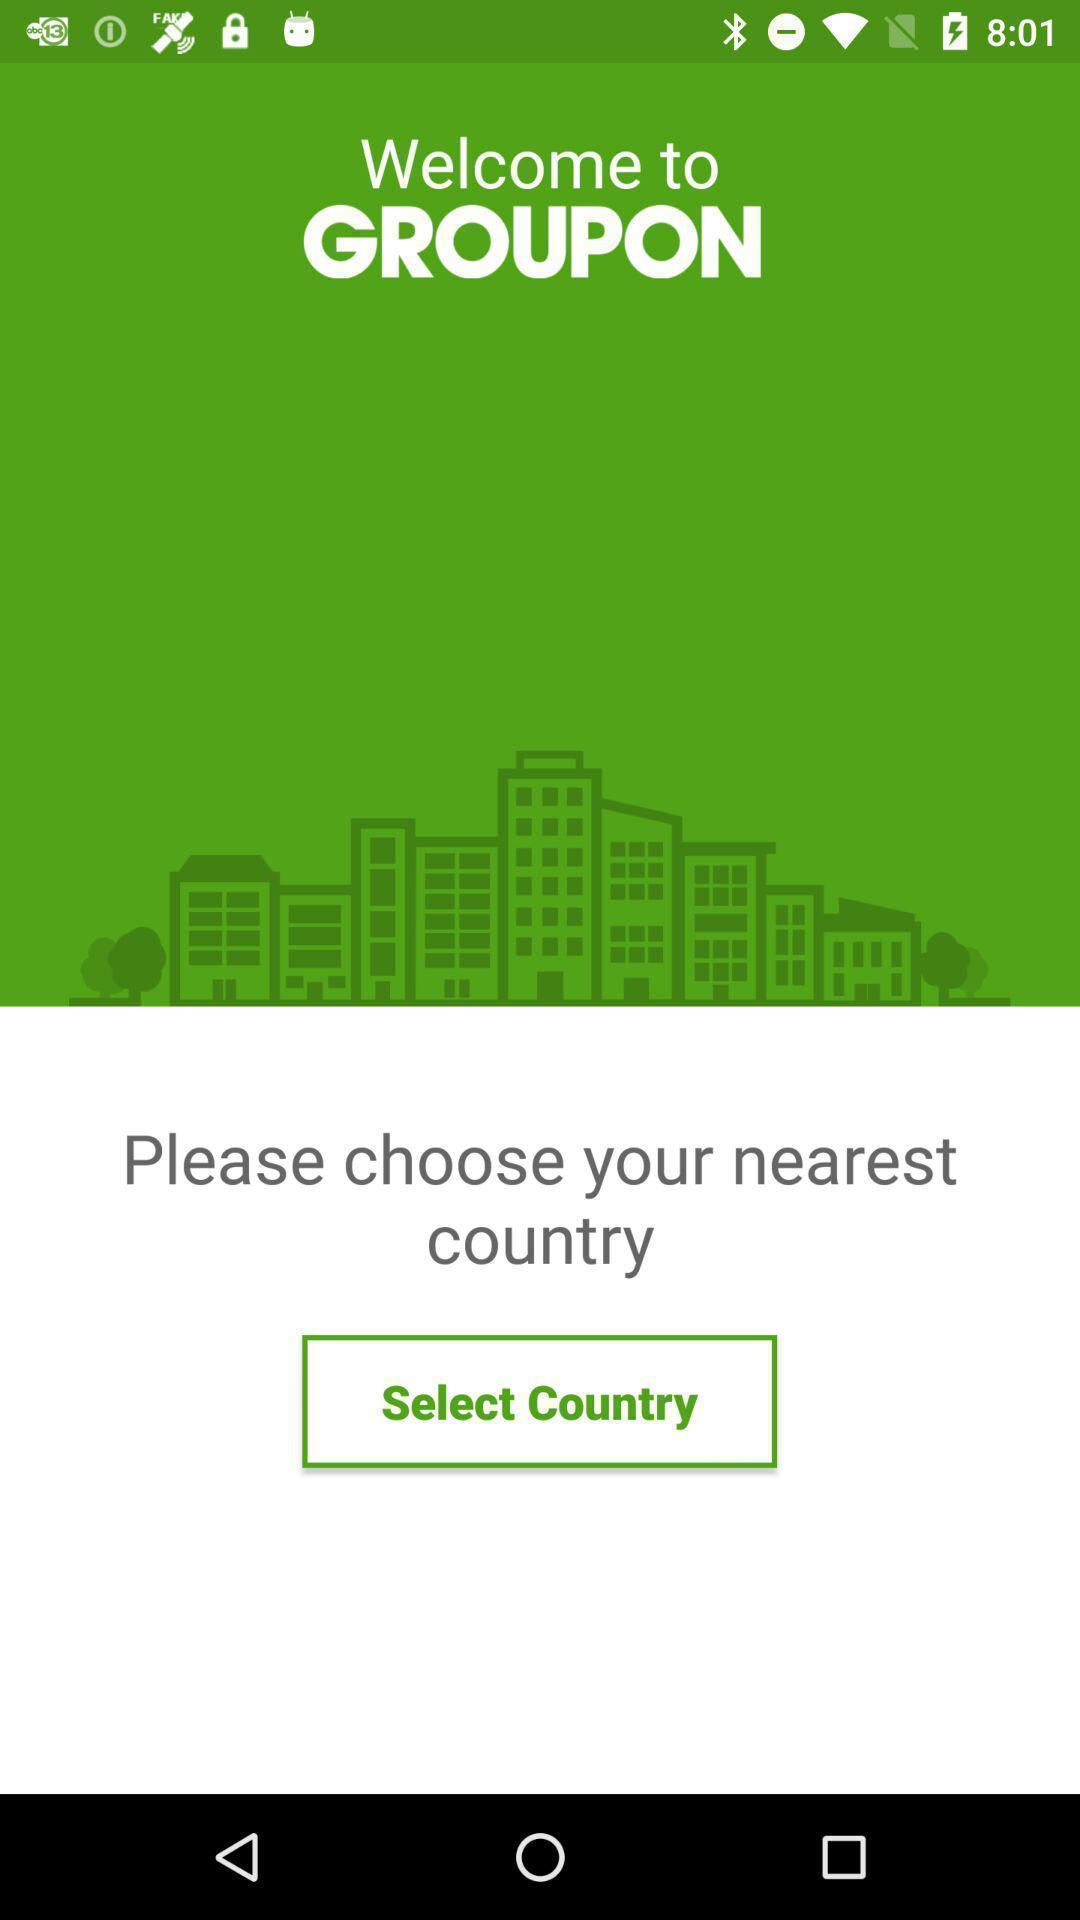Provide a description of this screenshot. Welcome page. 